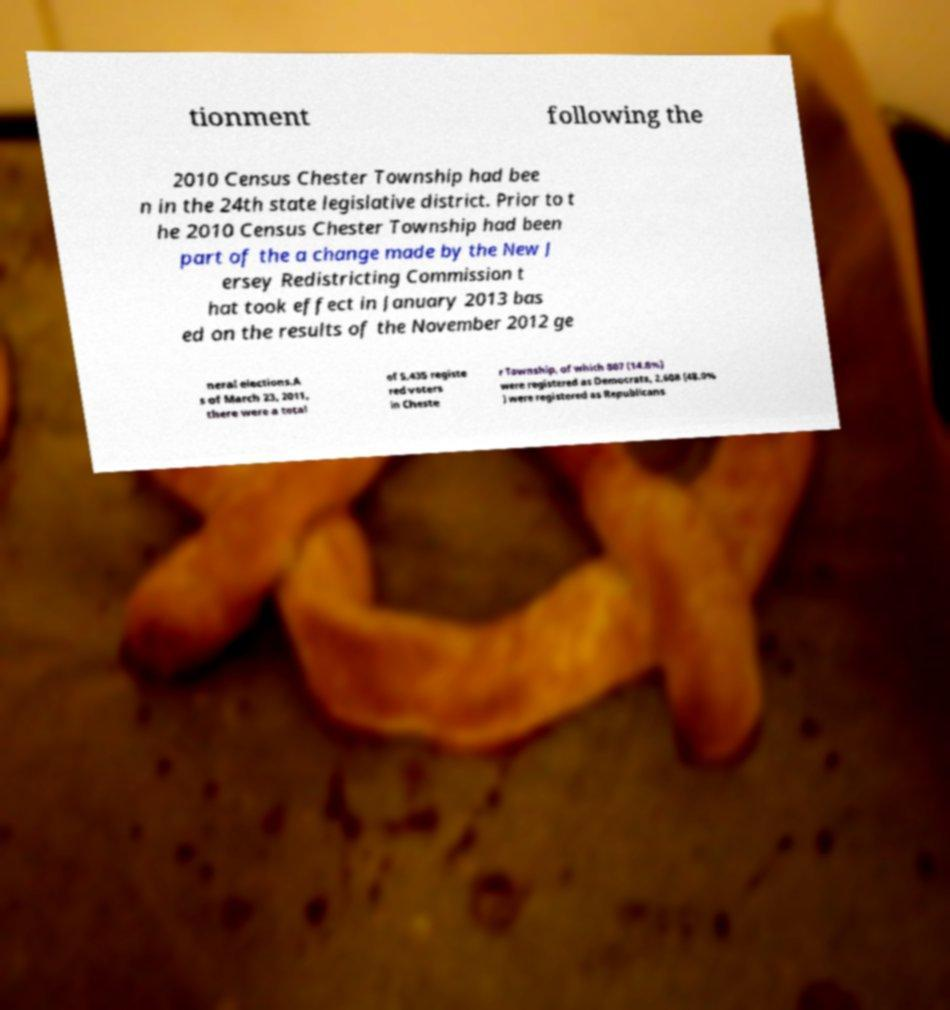Please read and relay the text visible in this image. What does it say? tionment following the 2010 Census Chester Township had bee n in the 24th state legislative district. Prior to t he 2010 Census Chester Township had been part of the a change made by the New J ersey Redistricting Commission t hat took effect in January 2013 bas ed on the results of the November 2012 ge neral elections.A s of March 23, 2011, there were a total of 5,435 registe red voters in Cheste r Township, of which 807 (14.8%) were registered as Democrats, 2,608 (48.0% ) were registered as Republicans 